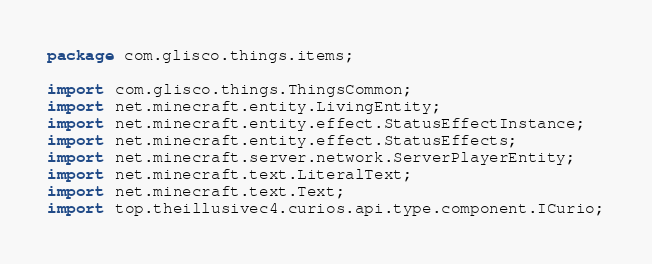Convert code to text. <code><loc_0><loc_0><loc_500><loc_500><_Java_>package com.glisco.things.items;

import com.glisco.things.ThingsCommon;
import net.minecraft.entity.LivingEntity;
import net.minecraft.entity.effect.StatusEffectInstance;
import net.minecraft.entity.effect.StatusEffects;
import net.minecraft.server.network.ServerPlayerEntity;
import net.minecraft.text.LiteralText;
import net.minecraft.text.Text;
import top.theillusivec4.curios.api.type.component.ICurio;
</code> 